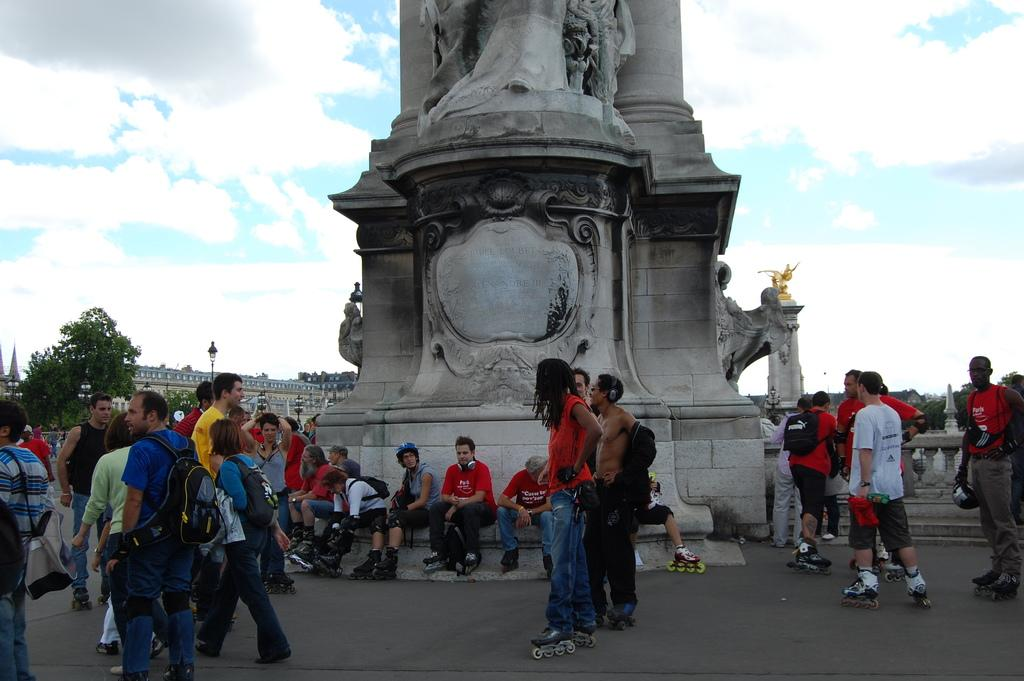What is happening in the image? There are people gathered in the image. What can be seen at the center of the gathering? There is a statue at the middle of the image. What is visible behind the people and the statue? The background of the image is the sky. How many legs can be seen on the statue in the image? The provided facts do not mention the number of legs on the statue, and therefore it cannot be determined from the image. What type of kick is being performed by the people in the image? There is no indication of any kicking activity in the image; the people are simply gathered around the statue. 